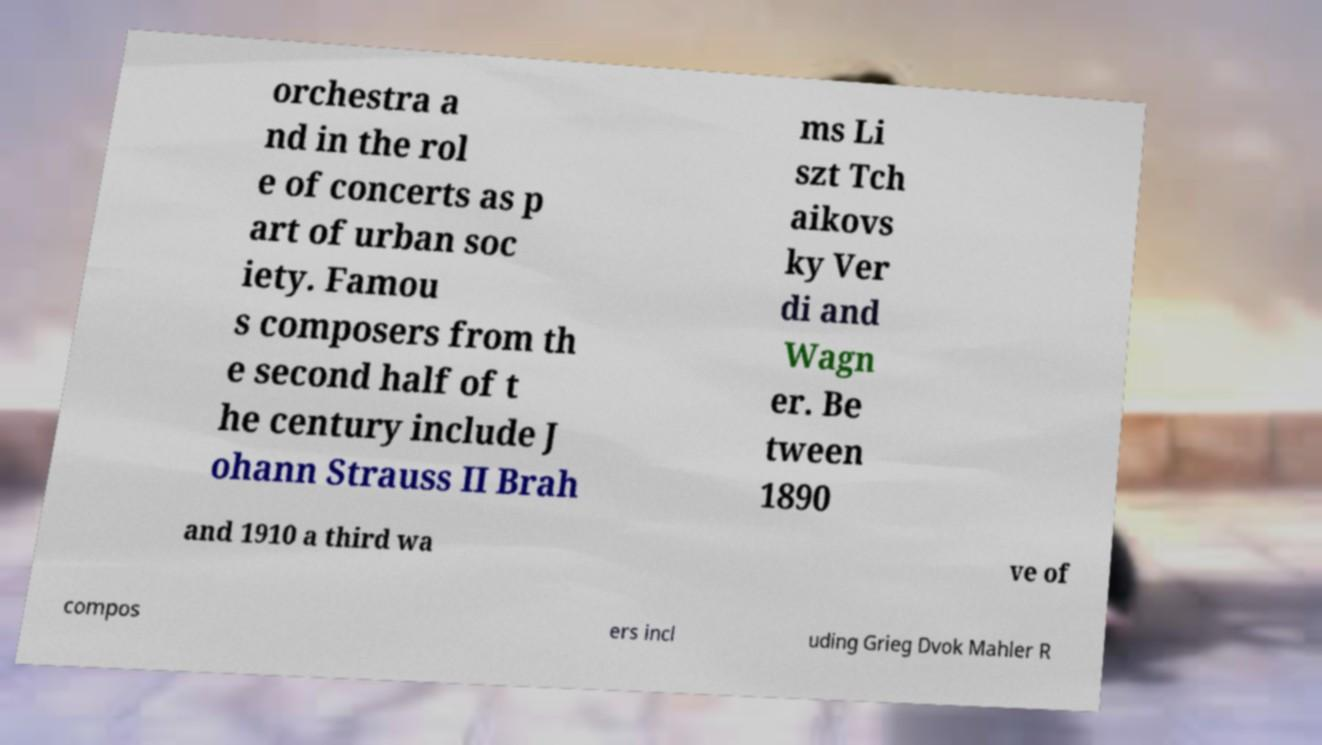Can you read and provide the text displayed in the image?This photo seems to have some interesting text. Can you extract and type it out for me? orchestra a nd in the rol e of concerts as p art of urban soc iety. Famou s composers from th e second half of t he century include J ohann Strauss II Brah ms Li szt Tch aikovs ky Ver di and Wagn er. Be tween 1890 and 1910 a third wa ve of compos ers incl uding Grieg Dvok Mahler R 